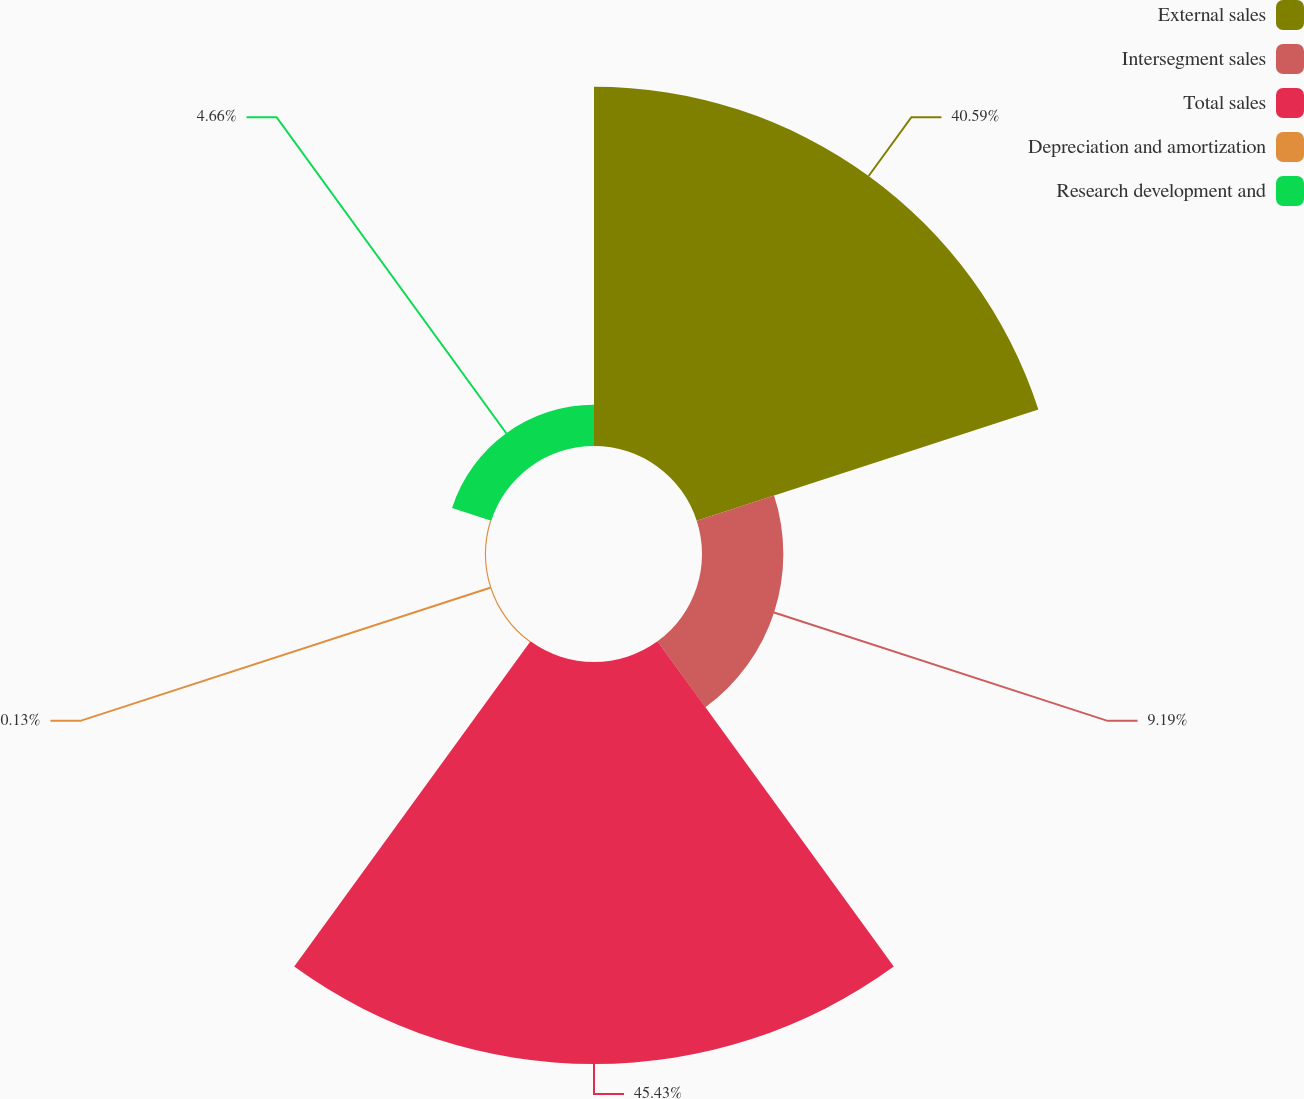<chart> <loc_0><loc_0><loc_500><loc_500><pie_chart><fcel>External sales<fcel>Intersegment sales<fcel>Total sales<fcel>Depreciation and amortization<fcel>Research development and<nl><fcel>40.59%<fcel>9.19%<fcel>45.42%<fcel>0.13%<fcel>4.66%<nl></chart> 